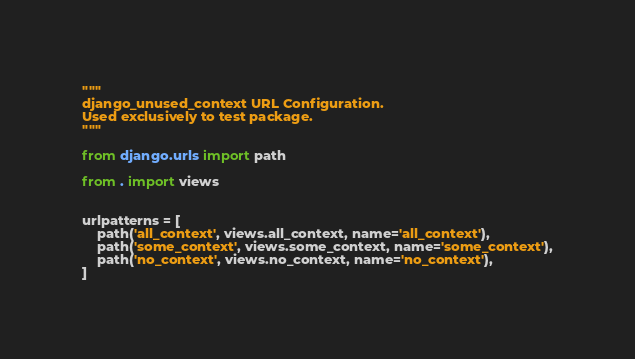<code> <loc_0><loc_0><loc_500><loc_500><_Python_>"""
django_unused_context URL Configuration.
Used exclusively to test package.
"""

from django.urls import path

from . import views


urlpatterns = [
    path('all_context', views.all_context, name='all_context'),
    path('some_context', views.some_context, name='some_context'),
    path('no_context', views.no_context, name='no_context'),
]
</code> 